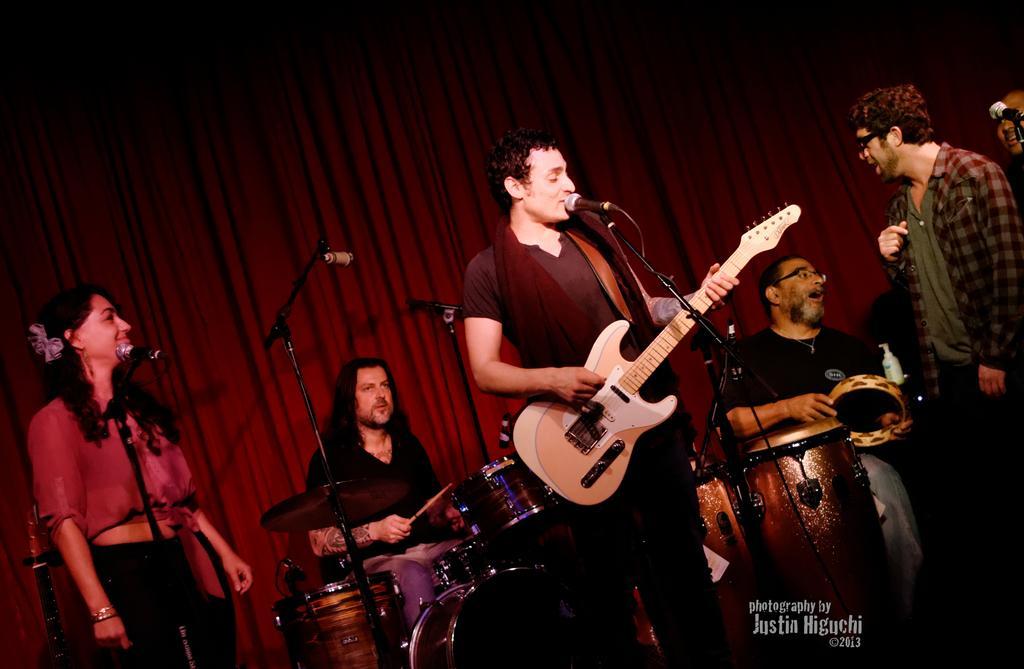How would you summarize this image in a sentence or two? There is a music band on the floor. Everybody is having one musical instrument in front of them. There is a microphone and a stand here. One woman is singing, the remaining guys are playing the musical instruments. In the background, there is a red color curtain here. 